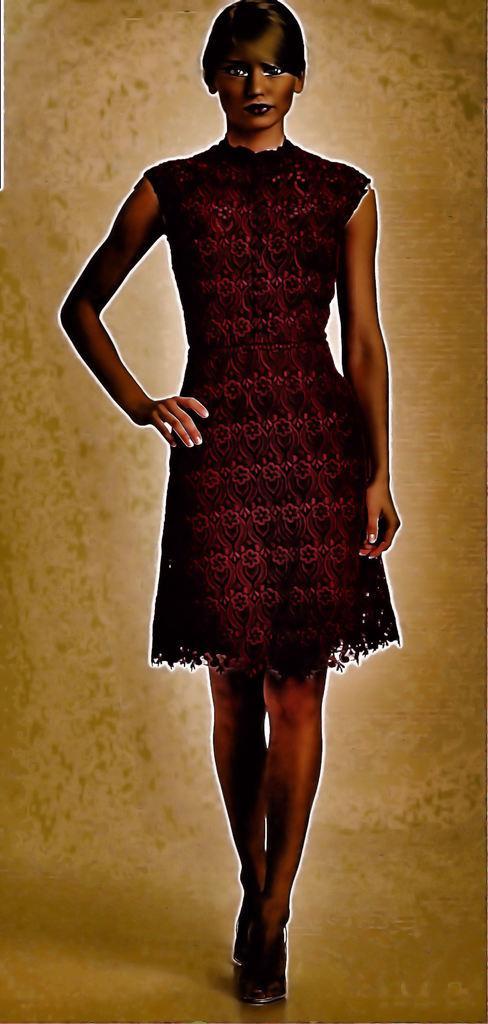Describe this image in one or two sentences. In this image we can see a woman standing on the floor. 